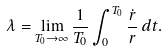<formula> <loc_0><loc_0><loc_500><loc_500>\lambda = \lim _ { T _ { 0 } \rightarrow \infty } \frac { 1 } { T _ { 0 } } \int _ { 0 } ^ { T _ { 0 } } \frac { \dot { r } } { r } \, d t .</formula> 